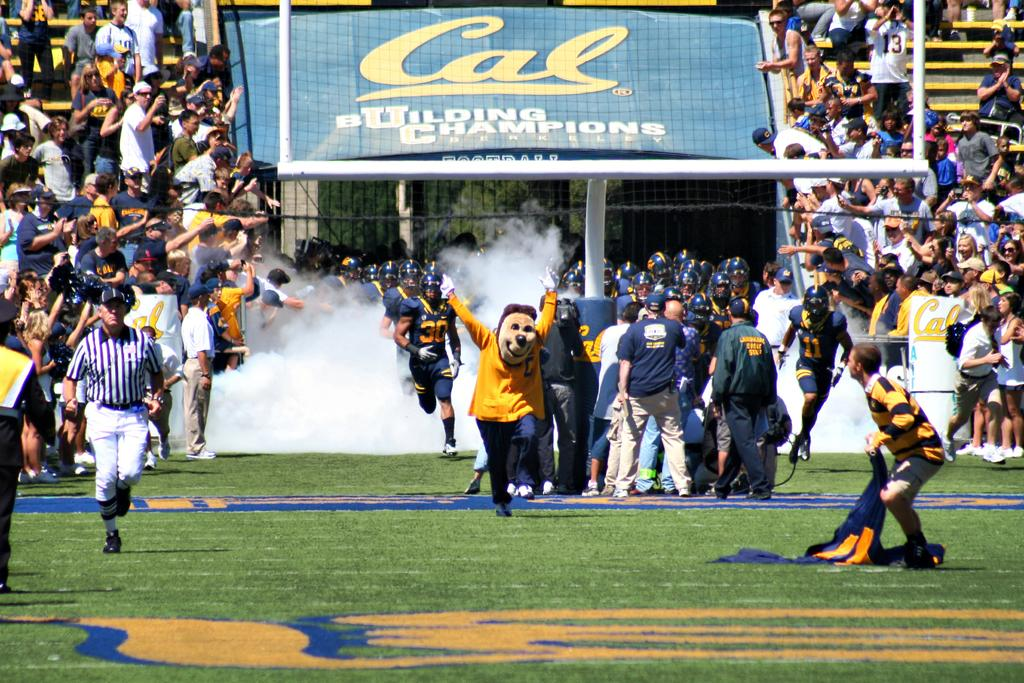<image>
Create a compact narrative representing the image presented. The coach and a mascot with the football player begins to run out on the field with the word Cal on a blue sign. 